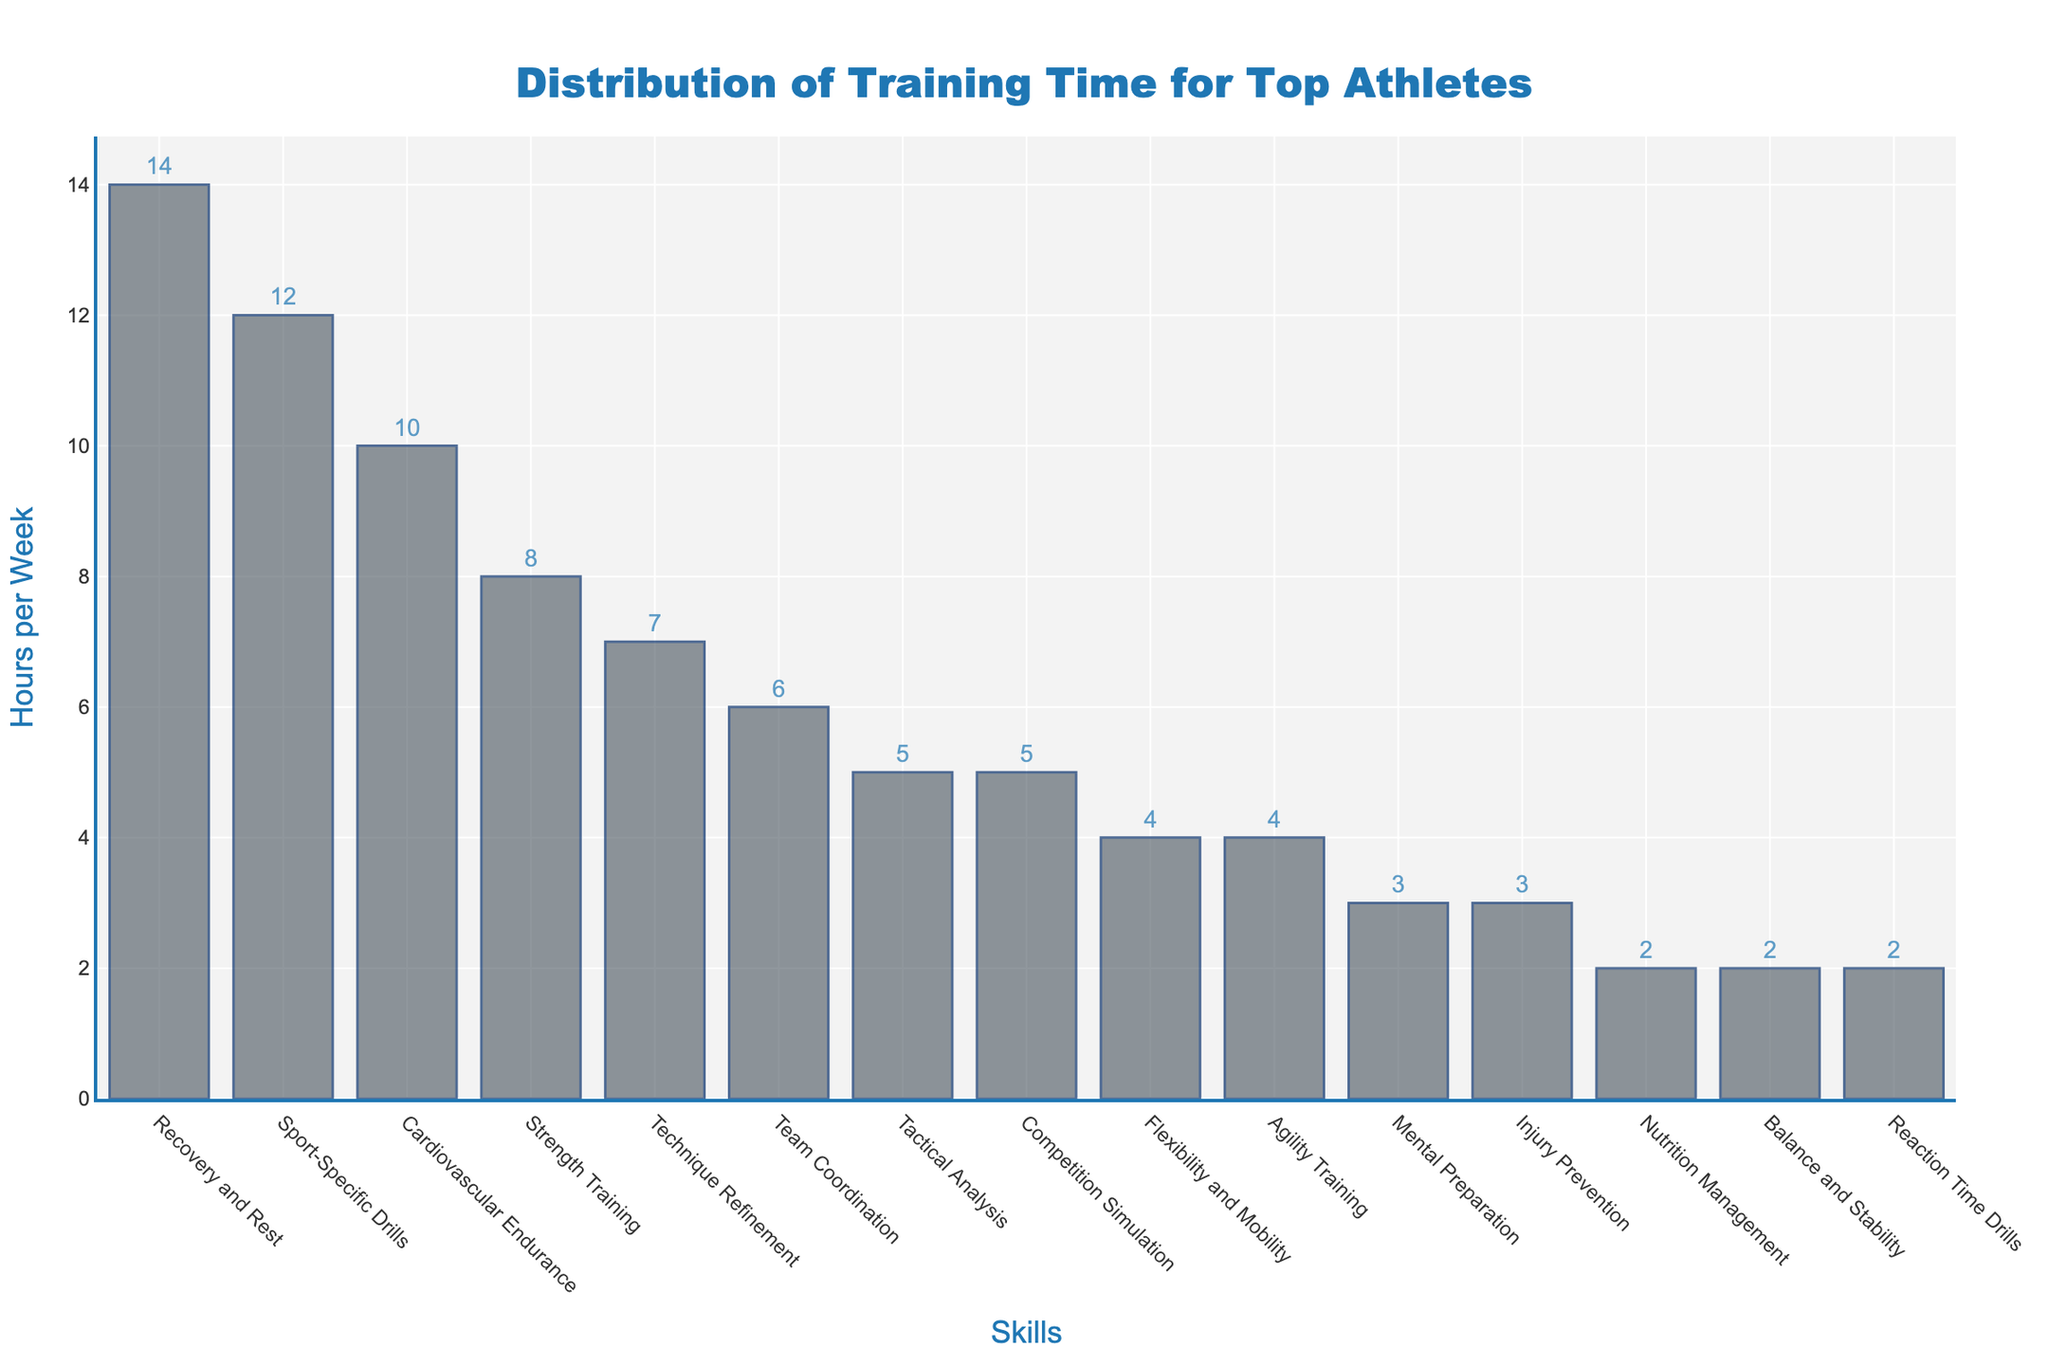What's the skill on which athletes spend the most training time? By visually inspecting the height of each bar, the highest bar represents the skill with the most training time. The bar for "Recovery and Rest" is the tallest.
Answer: Recovery and Rest Which skill has the least training time, and how many hours are spent on it? Look for the shortest bar in the figure. The shortest bar corresponds to both "Nutrition Management" and "Balance and Stability", with each showing the same value.
Answer: 2 hours How much more time is spent on Strength Training compared to Cardiovascular Endurance? Find the bars for "Strength Training" and "Cardiovascular Endurance". "Strength Training": 8 hours. "Cardiovascular Endurance": 10 hours. Calculate the difference: 10 - 8 = 2 hours more for Cardiovascular Endurance.
Answer: 2 hours less What is the combined total of hours spent on Mental Preparation and Tactical Analysis? Identify the bars for "Mental Preparation" and "Tactical Analysis". Add their heights: 3 hours (Mental Preparation) + 5 hours (Tactical Analysis) = 8 hours in total.
Answer: 8 hours Which skill-related bar is positioned in the middle when skills are sorted by training time, and what is its training time? With 15 skills listed, the middle position when sorted by training hours is 8th. The 8th bar from the ranked order is "Team Coordination" with 6 hours.
Answer: Team Coordination, 6 hours How many hours are spent on skills related to direct physical performance (Strength Training, Cardiovascular Endurance, Agility Training, Balance and Stability)? Sum the hours for each of these skills: Strength Training (8) + Cardiovascular Endurance (10) + Agility Training (4) + Balance and Stability (2). The total is 24 hours.
Answer: 24 hours Compare the training time between Sport-Specific Drills and Technique Refinement. Which one is greater, and by how much? Locate the bars for "Sport-Specific Drills" (12 hours) and "Technique Refinement" (7 hours). Calculate the difference: 12 - 7 = 5 hours.
Answer: Sport-Specific Drills, 5 hours What is the average time spent on Recovery and Rest, Mental Preparation, and Nutrition Management? Sum the hours for these three skills and divide by the number of skills: (14 + 3 + 2) / 3 = 19 / 3 ≈ 6.33 hours.
Answer: 6.33 hours If we combine the time spent on Flexibility and Mobility, Agility Training, and Reaction Time Drills, how does this total compare to the time spent on Competition Simulation? Calculate the combined total: Flexibility and Mobility (4) + Agility Training (4) + Reaction Time Drills (2) = 10 hours. Compare to Competition Simulation (5 hours): 10 > 5.
Answer: Combined total is 5 hours more What is the sum of the training times for Injury Prevention and Technique Refinement? Add the hours for "Injury Prevention" (3 hours) and "Technique Refinement" (7 hours): 3 + 7 = 10 hours.
Answer: 10 hours 